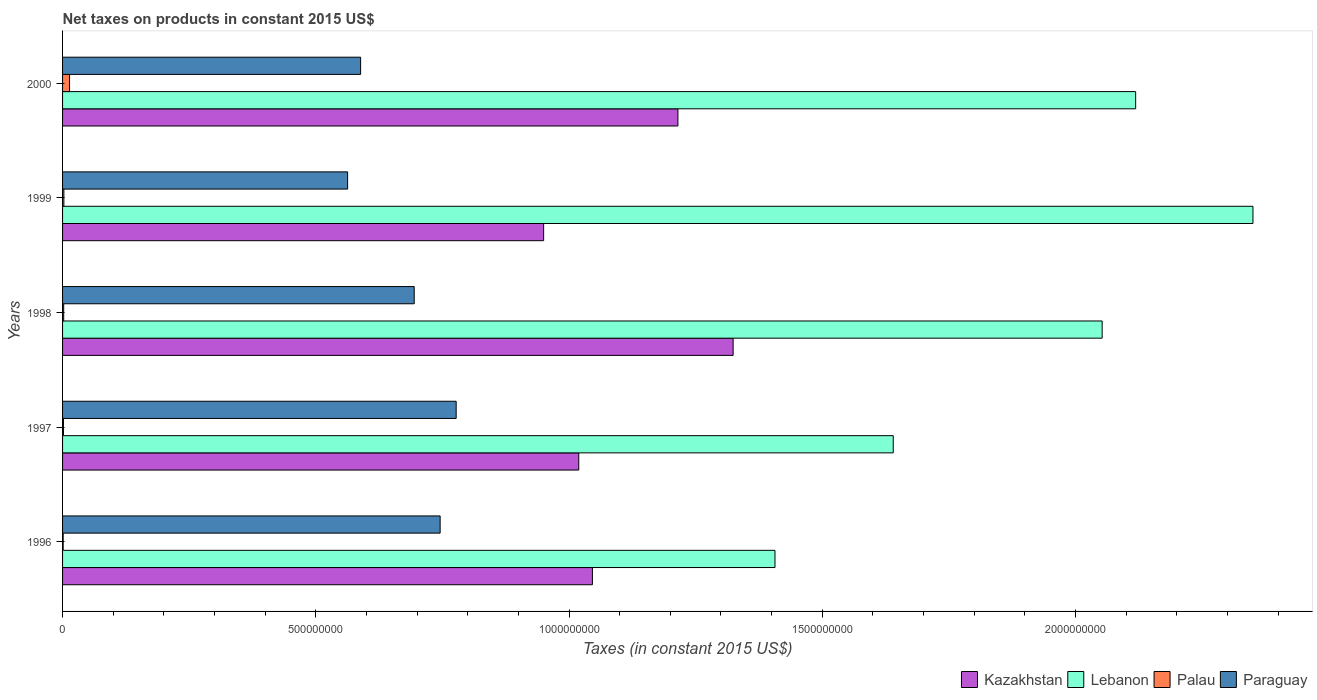Are the number of bars per tick equal to the number of legend labels?
Provide a succinct answer. Yes. How many bars are there on the 3rd tick from the top?
Your answer should be compact. 4. How many bars are there on the 1st tick from the bottom?
Make the answer very short. 4. What is the label of the 2nd group of bars from the top?
Your answer should be very brief. 1999. In how many cases, is the number of bars for a given year not equal to the number of legend labels?
Your answer should be compact. 0. What is the net taxes on products in Palau in 1999?
Your answer should be very brief. 2.59e+06. Across all years, what is the maximum net taxes on products in Lebanon?
Make the answer very short. 2.35e+09. Across all years, what is the minimum net taxes on products in Palau?
Your response must be concise. 1.20e+06. What is the total net taxes on products in Kazakhstan in the graph?
Your response must be concise. 5.55e+09. What is the difference between the net taxes on products in Kazakhstan in 1999 and that in 2000?
Offer a terse response. -2.65e+08. What is the difference between the net taxes on products in Kazakhstan in 1998 and the net taxes on products in Paraguay in 1999?
Your response must be concise. 7.61e+08. What is the average net taxes on products in Palau per year?
Provide a succinct answer. 4.31e+06. In the year 1997, what is the difference between the net taxes on products in Kazakhstan and net taxes on products in Paraguay?
Ensure brevity in your answer.  2.42e+08. In how many years, is the net taxes on products in Kazakhstan greater than 1100000000 US$?
Provide a short and direct response. 2. What is the ratio of the net taxes on products in Paraguay in 1997 to that in 1999?
Give a very brief answer. 1.38. Is the net taxes on products in Palau in 1996 less than that in 1999?
Offer a very short reply. Yes. What is the difference between the highest and the second highest net taxes on products in Lebanon?
Provide a succinct answer. 2.32e+08. What is the difference between the highest and the lowest net taxes on products in Palau?
Offer a terse response. 1.26e+07. In how many years, is the net taxes on products in Kazakhstan greater than the average net taxes on products in Kazakhstan taken over all years?
Your answer should be compact. 2. What does the 2nd bar from the top in 1996 represents?
Keep it short and to the point. Palau. What does the 1st bar from the bottom in 1996 represents?
Your answer should be compact. Kazakhstan. Are all the bars in the graph horizontal?
Your answer should be very brief. Yes. How many years are there in the graph?
Your response must be concise. 5. Where does the legend appear in the graph?
Offer a very short reply. Bottom right. What is the title of the graph?
Provide a short and direct response. Net taxes on products in constant 2015 US$. Does "St. Kitts and Nevis" appear as one of the legend labels in the graph?
Provide a succinct answer. No. What is the label or title of the X-axis?
Your answer should be compact. Taxes (in constant 2015 US$). What is the label or title of the Y-axis?
Offer a terse response. Years. What is the Taxes (in constant 2015 US$) of Kazakhstan in 1996?
Provide a succinct answer. 1.05e+09. What is the Taxes (in constant 2015 US$) in Lebanon in 1996?
Provide a succinct answer. 1.41e+09. What is the Taxes (in constant 2015 US$) in Palau in 1996?
Offer a very short reply. 1.20e+06. What is the Taxes (in constant 2015 US$) in Paraguay in 1996?
Provide a succinct answer. 7.45e+08. What is the Taxes (in constant 2015 US$) of Kazakhstan in 1997?
Your answer should be compact. 1.02e+09. What is the Taxes (in constant 2015 US$) of Lebanon in 1997?
Your answer should be compact. 1.64e+09. What is the Taxes (in constant 2015 US$) of Palau in 1997?
Provide a short and direct response. 1.74e+06. What is the Taxes (in constant 2015 US$) of Paraguay in 1997?
Offer a terse response. 7.77e+08. What is the Taxes (in constant 2015 US$) in Kazakhstan in 1998?
Your response must be concise. 1.32e+09. What is the Taxes (in constant 2015 US$) in Lebanon in 1998?
Provide a succinct answer. 2.05e+09. What is the Taxes (in constant 2015 US$) of Palau in 1998?
Provide a succinct answer. 2.23e+06. What is the Taxes (in constant 2015 US$) in Paraguay in 1998?
Give a very brief answer. 6.94e+08. What is the Taxes (in constant 2015 US$) of Kazakhstan in 1999?
Offer a terse response. 9.50e+08. What is the Taxes (in constant 2015 US$) of Lebanon in 1999?
Offer a terse response. 2.35e+09. What is the Taxes (in constant 2015 US$) in Palau in 1999?
Your response must be concise. 2.59e+06. What is the Taxes (in constant 2015 US$) in Paraguay in 1999?
Keep it short and to the point. 5.63e+08. What is the Taxes (in constant 2015 US$) in Kazakhstan in 2000?
Make the answer very short. 1.21e+09. What is the Taxes (in constant 2015 US$) of Lebanon in 2000?
Provide a short and direct response. 2.12e+09. What is the Taxes (in constant 2015 US$) of Palau in 2000?
Make the answer very short. 1.38e+07. What is the Taxes (in constant 2015 US$) in Paraguay in 2000?
Your answer should be compact. 5.88e+08. Across all years, what is the maximum Taxes (in constant 2015 US$) in Kazakhstan?
Keep it short and to the point. 1.32e+09. Across all years, what is the maximum Taxes (in constant 2015 US$) of Lebanon?
Offer a terse response. 2.35e+09. Across all years, what is the maximum Taxes (in constant 2015 US$) in Palau?
Make the answer very short. 1.38e+07. Across all years, what is the maximum Taxes (in constant 2015 US$) of Paraguay?
Offer a very short reply. 7.77e+08. Across all years, what is the minimum Taxes (in constant 2015 US$) in Kazakhstan?
Give a very brief answer. 9.50e+08. Across all years, what is the minimum Taxes (in constant 2015 US$) in Lebanon?
Your answer should be compact. 1.41e+09. Across all years, what is the minimum Taxes (in constant 2015 US$) of Palau?
Keep it short and to the point. 1.20e+06. Across all years, what is the minimum Taxes (in constant 2015 US$) of Paraguay?
Ensure brevity in your answer.  5.63e+08. What is the total Taxes (in constant 2015 US$) of Kazakhstan in the graph?
Your response must be concise. 5.55e+09. What is the total Taxes (in constant 2015 US$) of Lebanon in the graph?
Your answer should be compact. 9.57e+09. What is the total Taxes (in constant 2015 US$) in Palau in the graph?
Ensure brevity in your answer.  2.16e+07. What is the total Taxes (in constant 2015 US$) in Paraguay in the graph?
Give a very brief answer. 3.37e+09. What is the difference between the Taxes (in constant 2015 US$) of Kazakhstan in 1996 and that in 1997?
Provide a short and direct response. 2.69e+07. What is the difference between the Taxes (in constant 2015 US$) in Lebanon in 1996 and that in 1997?
Provide a short and direct response. -2.34e+08. What is the difference between the Taxes (in constant 2015 US$) in Palau in 1996 and that in 1997?
Your response must be concise. -5.43e+05. What is the difference between the Taxes (in constant 2015 US$) in Paraguay in 1996 and that in 1997?
Ensure brevity in your answer.  -3.17e+07. What is the difference between the Taxes (in constant 2015 US$) in Kazakhstan in 1996 and that in 1998?
Your answer should be very brief. -2.78e+08. What is the difference between the Taxes (in constant 2015 US$) of Lebanon in 1996 and that in 1998?
Your answer should be compact. -6.46e+08. What is the difference between the Taxes (in constant 2015 US$) of Palau in 1996 and that in 1998?
Your answer should be compact. -1.03e+06. What is the difference between the Taxes (in constant 2015 US$) of Paraguay in 1996 and that in 1998?
Your answer should be compact. 5.12e+07. What is the difference between the Taxes (in constant 2015 US$) in Kazakhstan in 1996 and that in 1999?
Make the answer very short. 9.63e+07. What is the difference between the Taxes (in constant 2015 US$) in Lebanon in 1996 and that in 1999?
Your answer should be very brief. -9.44e+08. What is the difference between the Taxes (in constant 2015 US$) of Palau in 1996 and that in 1999?
Ensure brevity in your answer.  -1.39e+06. What is the difference between the Taxes (in constant 2015 US$) of Paraguay in 1996 and that in 1999?
Give a very brief answer. 1.83e+08. What is the difference between the Taxes (in constant 2015 US$) of Kazakhstan in 1996 and that in 2000?
Keep it short and to the point. -1.69e+08. What is the difference between the Taxes (in constant 2015 US$) of Lebanon in 1996 and that in 2000?
Provide a succinct answer. -7.12e+08. What is the difference between the Taxes (in constant 2015 US$) of Palau in 1996 and that in 2000?
Keep it short and to the point. -1.26e+07. What is the difference between the Taxes (in constant 2015 US$) in Paraguay in 1996 and that in 2000?
Offer a terse response. 1.57e+08. What is the difference between the Taxes (in constant 2015 US$) of Kazakhstan in 1997 and that in 1998?
Keep it short and to the point. -3.05e+08. What is the difference between the Taxes (in constant 2015 US$) of Lebanon in 1997 and that in 1998?
Offer a terse response. -4.12e+08. What is the difference between the Taxes (in constant 2015 US$) of Palau in 1997 and that in 1998?
Make the answer very short. -4.88e+05. What is the difference between the Taxes (in constant 2015 US$) of Paraguay in 1997 and that in 1998?
Provide a short and direct response. 8.28e+07. What is the difference between the Taxes (in constant 2015 US$) in Kazakhstan in 1997 and that in 1999?
Your answer should be very brief. 6.93e+07. What is the difference between the Taxes (in constant 2015 US$) in Lebanon in 1997 and that in 1999?
Provide a short and direct response. -7.10e+08. What is the difference between the Taxes (in constant 2015 US$) in Palau in 1997 and that in 1999?
Your answer should be compact. -8.47e+05. What is the difference between the Taxes (in constant 2015 US$) of Paraguay in 1997 and that in 1999?
Your response must be concise. 2.14e+08. What is the difference between the Taxes (in constant 2015 US$) in Kazakhstan in 1997 and that in 2000?
Give a very brief answer. -1.96e+08. What is the difference between the Taxes (in constant 2015 US$) of Lebanon in 1997 and that in 2000?
Your answer should be very brief. -4.79e+08. What is the difference between the Taxes (in constant 2015 US$) of Palau in 1997 and that in 2000?
Provide a short and direct response. -1.21e+07. What is the difference between the Taxes (in constant 2015 US$) in Paraguay in 1997 and that in 2000?
Give a very brief answer. 1.89e+08. What is the difference between the Taxes (in constant 2015 US$) in Kazakhstan in 1998 and that in 1999?
Ensure brevity in your answer.  3.74e+08. What is the difference between the Taxes (in constant 2015 US$) of Lebanon in 1998 and that in 1999?
Keep it short and to the point. -2.98e+08. What is the difference between the Taxes (in constant 2015 US$) in Palau in 1998 and that in 1999?
Give a very brief answer. -3.59e+05. What is the difference between the Taxes (in constant 2015 US$) of Paraguay in 1998 and that in 1999?
Your response must be concise. 1.32e+08. What is the difference between the Taxes (in constant 2015 US$) in Kazakhstan in 1998 and that in 2000?
Make the answer very short. 1.09e+08. What is the difference between the Taxes (in constant 2015 US$) of Lebanon in 1998 and that in 2000?
Make the answer very short. -6.61e+07. What is the difference between the Taxes (in constant 2015 US$) in Palau in 1998 and that in 2000?
Offer a terse response. -1.16e+07. What is the difference between the Taxes (in constant 2015 US$) in Paraguay in 1998 and that in 2000?
Offer a very short reply. 1.06e+08. What is the difference between the Taxes (in constant 2015 US$) in Kazakhstan in 1999 and that in 2000?
Ensure brevity in your answer.  -2.65e+08. What is the difference between the Taxes (in constant 2015 US$) of Lebanon in 1999 and that in 2000?
Make the answer very short. 2.32e+08. What is the difference between the Taxes (in constant 2015 US$) of Palau in 1999 and that in 2000?
Make the answer very short. -1.12e+07. What is the difference between the Taxes (in constant 2015 US$) of Paraguay in 1999 and that in 2000?
Provide a short and direct response. -2.57e+07. What is the difference between the Taxes (in constant 2015 US$) of Kazakhstan in 1996 and the Taxes (in constant 2015 US$) of Lebanon in 1997?
Ensure brevity in your answer.  -5.94e+08. What is the difference between the Taxes (in constant 2015 US$) in Kazakhstan in 1996 and the Taxes (in constant 2015 US$) in Palau in 1997?
Your answer should be very brief. 1.04e+09. What is the difference between the Taxes (in constant 2015 US$) in Kazakhstan in 1996 and the Taxes (in constant 2015 US$) in Paraguay in 1997?
Offer a terse response. 2.69e+08. What is the difference between the Taxes (in constant 2015 US$) of Lebanon in 1996 and the Taxes (in constant 2015 US$) of Palau in 1997?
Your answer should be very brief. 1.40e+09. What is the difference between the Taxes (in constant 2015 US$) in Lebanon in 1996 and the Taxes (in constant 2015 US$) in Paraguay in 1997?
Keep it short and to the point. 6.29e+08. What is the difference between the Taxes (in constant 2015 US$) of Palau in 1996 and the Taxes (in constant 2015 US$) of Paraguay in 1997?
Your response must be concise. -7.76e+08. What is the difference between the Taxes (in constant 2015 US$) of Kazakhstan in 1996 and the Taxes (in constant 2015 US$) of Lebanon in 1998?
Provide a short and direct response. -1.01e+09. What is the difference between the Taxes (in constant 2015 US$) in Kazakhstan in 1996 and the Taxes (in constant 2015 US$) in Palau in 1998?
Your response must be concise. 1.04e+09. What is the difference between the Taxes (in constant 2015 US$) of Kazakhstan in 1996 and the Taxes (in constant 2015 US$) of Paraguay in 1998?
Make the answer very short. 3.52e+08. What is the difference between the Taxes (in constant 2015 US$) of Lebanon in 1996 and the Taxes (in constant 2015 US$) of Palau in 1998?
Offer a very short reply. 1.40e+09. What is the difference between the Taxes (in constant 2015 US$) of Lebanon in 1996 and the Taxes (in constant 2015 US$) of Paraguay in 1998?
Provide a succinct answer. 7.12e+08. What is the difference between the Taxes (in constant 2015 US$) of Palau in 1996 and the Taxes (in constant 2015 US$) of Paraguay in 1998?
Provide a succinct answer. -6.93e+08. What is the difference between the Taxes (in constant 2015 US$) in Kazakhstan in 1996 and the Taxes (in constant 2015 US$) in Lebanon in 1999?
Your answer should be very brief. -1.30e+09. What is the difference between the Taxes (in constant 2015 US$) of Kazakhstan in 1996 and the Taxes (in constant 2015 US$) of Palau in 1999?
Your answer should be very brief. 1.04e+09. What is the difference between the Taxes (in constant 2015 US$) in Kazakhstan in 1996 and the Taxes (in constant 2015 US$) in Paraguay in 1999?
Provide a short and direct response. 4.83e+08. What is the difference between the Taxes (in constant 2015 US$) in Lebanon in 1996 and the Taxes (in constant 2015 US$) in Palau in 1999?
Provide a succinct answer. 1.40e+09. What is the difference between the Taxes (in constant 2015 US$) of Lebanon in 1996 and the Taxes (in constant 2015 US$) of Paraguay in 1999?
Your answer should be compact. 8.44e+08. What is the difference between the Taxes (in constant 2015 US$) of Palau in 1996 and the Taxes (in constant 2015 US$) of Paraguay in 1999?
Your response must be concise. -5.62e+08. What is the difference between the Taxes (in constant 2015 US$) in Kazakhstan in 1996 and the Taxes (in constant 2015 US$) in Lebanon in 2000?
Your answer should be compact. -1.07e+09. What is the difference between the Taxes (in constant 2015 US$) of Kazakhstan in 1996 and the Taxes (in constant 2015 US$) of Palau in 2000?
Offer a very short reply. 1.03e+09. What is the difference between the Taxes (in constant 2015 US$) of Kazakhstan in 1996 and the Taxes (in constant 2015 US$) of Paraguay in 2000?
Provide a short and direct response. 4.58e+08. What is the difference between the Taxes (in constant 2015 US$) in Lebanon in 1996 and the Taxes (in constant 2015 US$) in Palau in 2000?
Your answer should be compact. 1.39e+09. What is the difference between the Taxes (in constant 2015 US$) of Lebanon in 1996 and the Taxes (in constant 2015 US$) of Paraguay in 2000?
Offer a very short reply. 8.18e+08. What is the difference between the Taxes (in constant 2015 US$) in Palau in 1996 and the Taxes (in constant 2015 US$) in Paraguay in 2000?
Keep it short and to the point. -5.87e+08. What is the difference between the Taxes (in constant 2015 US$) in Kazakhstan in 1997 and the Taxes (in constant 2015 US$) in Lebanon in 1998?
Your answer should be very brief. -1.03e+09. What is the difference between the Taxes (in constant 2015 US$) in Kazakhstan in 1997 and the Taxes (in constant 2015 US$) in Palau in 1998?
Offer a very short reply. 1.02e+09. What is the difference between the Taxes (in constant 2015 US$) in Kazakhstan in 1997 and the Taxes (in constant 2015 US$) in Paraguay in 1998?
Your response must be concise. 3.25e+08. What is the difference between the Taxes (in constant 2015 US$) of Lebanon in 1997 and the Taxes (in constant 2015 US$) of Palau in 1998?
Ensure brevity in your answer.  1.64e+09. What is the difference between the Taxes (in constant 2015 US$) of Lebanon in 1997 and the Taxes (in constant 2015 US$) of Paraguay in 1998?
Your answer should be very brief. 9.46e+08. What is the difference between the Taxes (in constant 2015 US$) of Palau in 1997 and the Taxes (in constant 2015 US$) of Paraguay in 1998?
Your answer should be compact. -6.93e+08. What is the difference between the Taxes (in constant 2015 US$) in Kazakhstan in 1997 and the Taxes (in constant 2015 US$) in Lebanon in 1999?
Provide a succinct answer. -1.33e+09. What is the difference between the Taxes (in constant 2015 US$) in Kazakhstan in 1997 and the Taxes (in constant 2015 US$) in Palau in 1999?
Your answer should be compact. 1.02e+09. What is the difference between the Taxes (in constant 2015 US$) of Kazakhstan in 1997 and the Taxes (in constant 2015 US$) of Paraguay in 1999?
Ensure brevity in your answer.  4.56e+08. What is the difference between the Taxes (in constant 2015 US$) in Lebanon in 1997 and the Taxes (in constant 2015 US$) in Palau in 1999?
Your answer should be compact. 1.64e+09. What is the difference between the Taxes (in constant 2015 US$) of Lebanon in 1997 and the Taxes (in constant 2015 US$) of Paraguay in 1999?
Provide a short and direct response. 1.08e+09. What is the difference between the Taxes (in constant 2015 US$) in Palau in 1997 and the Taxes (in constant 2015 US$) in Paraguay in 1999?
Give a very brief answer. -5.61e+08. What is the difference between the Taxes (in constant 2015 US$) of Kazakhstan in 1997 and the Taxes (in constant 2015 US$) of Lebanon in 2000?
Provide a succinct answer. -1.10e+09. What is the difference between the Taxes (in constant 2015 US$) of Kazakhstan in 1997 and the Taxes (in constant 2015 US$) of Palau in 2000?
Keep it short and to the point. 1.01e+09. What is the difference between the Taxes (in constant 2015 US$) in Kazakhstan in 1997 and the Taxes (in constant 2015 US$) in Paraguay in 2000?
Keep it short and to the point. 4.31e+08. What is the difference between the Taxes (in constant 2015 US$) in Lebanon in 1997 and the Taxes (in constant 2015 US$) in Palau in 2000?
Keep it short and to the point. 1.63e+09. What is the difference between the Taxes (in constant 2015 US$) in Lebanon in 1997 and the Taxes (in constant 2015 US$) in Paraguay in 2000?
Keep it short and to the point. 1.05e+09. What is the difference between the Taxes (in constant 2015 US$) in Palau in 1997 and the Taxes (in constant 2015 US$) in Paraguay in 2000?
Offer a terse response. -5.87e+08. What is the difference between the Taxes (in constant 2015 US$) of Kazakhstan in 1998 and the Taxes (in constant 2015 US$) of Lebanon in 1999?
Provide a succinct answer. -1.03e+09. What is the difference between the Taxes (in constant 2015 US$) of Kazakhstan in 1998 and the Taxes (in constant 2015 US$) of Palau in 1999?
Give a very brief answer. 1.32e+09. What is the difference between the Taxes (in constant 2015 US$) in Kazakhstan in 1998 and the Taxes (in constant 2015 US$) in Paraguay in 1999?
Ensure brevity in your answer.  7.61e+08. What is the difference between the Taxes (in constant 2015 US$) of Lebanon in 1998 and the Taxes (in constant 2015 US$) of Palau in 1999?
Keep it short and to the point. 2.05e+09. What is the difference between the Taxes (in constant 2015 US$) in Lebanon in 1998 and the Taxes (in constant 2015 US$) in Paraguay in 1999?
Make the answer very short. 1.49e+09. What is the difference between the Taxes (in constant 2015 US$) of Palau in 1998 and the Taxes (in constant 2015 US$) of Paraguay in 1999?
Your answer should be very brief. -5.61e+08. What is the difference between the Taxes (in constant 2015 US$) in Kazakhstan in 1998 and the Taxes (in constant 2015 US$) in Lebanon in 2000?
Offer a very short reply. -7.95e+08. What is the difference between the Taxes (in constant 2015 US$) in Kazakhstan in 1998 and the Taxes (in constant 2015 US$) in Palau in 2000?
Ensure brevity in your answer.  1.31e+09. What is the difference between the Taxes (in constant 2015 US$) in Kazakhstan in 1998 and the Taxes (in constant 2015 US$) in Paraguay in 2000?
Provide a succinct answer. 7.35e+08. What is the difference between the Taxes (in constant 2015 US$) in Lebanon in 1998 and the Taxes (in constant 2015 US$) in Palau in 2000?
Provide a short and direct response. 2.04e+09. What is the difference between the Taxes (in constant 2015 US$) in Lebanon in 1998 and the Taxes (in constant 2015 US$) in Paraguay in 2000?
Your answer should be very brief. 1.46e+09. What is the difference between the Taxes (in constant 2015 US$) in Palau in 1998 and the Taxes (in constant 2015 US$) in Paraguay in 2000?
Give a very brief answer. -5.86e+08. What is the difference between the Taxes (in constant 2015 US$) of Kazakhstan in 1999 and the Taxes (in constant 2015 US$) of Lebanon in 2000?
Your response must be concise. -1.17e+09. What is the difference between the Taxes (in constant 2015 US$) in Kazakhstan in 1999 and the Taxes (in constant 2015 US$) in Palau in 2000?
Offer a terse response. 9.36e+08. What is the difference between the Taxes (in constant 2015 US$) of Kazakhstan in 1999 and the Taxes (in constant 2015 US$) of Paraguay in 2000?
Provide a short and direct response. 3.61e+08. What is the difference between the Taxes (in constant 2015 US$) of Lebanon in 1999 and the Taxes (in constant 2015 US$) of Palau in 2000?
Provide a short and direct response. 2.34e+09. What is the difference between the Taxes (in constant 2015 US$) in Lebanon in 1999 and the Taxes (in constant 2015 US$) in Paraguay in 2000?
Give a very brief answer. 1.76e+09. What is the difference between the Taxes (in constant 2015 US$) of Palau in 1999 and the Taxes (in constant 2015 US$) of Paraguay in 2000?
Your answer should be compact. -5.86e+08. What is the average Taxes (in constant 2015 US$) in Kazakhstan per year?
Keep it short and to the point. 1.11e+09. What is the average Taxes (in constant 2015 US$) in Lebanon per year?
Provide a succinct answer. 1.91e+09. What is the average Taxes (in constant 2015 US$) in Palau per year?
Keep it short and to the point. 4.31e+06. What is the average Taxes (in constant 2015 US$) in Paraguay per year?
Your answer should be very brief. 6.74e+08. In the year 1996, what is the difference between the Taxes (in constant 2015 US$) of Kazakhstan and Taxes (in constant 2015 US$) of Lebanon?
Keep it short and to the point. -3.60e+08. In the year 1996, what is the difference between the Taxes (in constant 2015 US$) in Kazakhstan and Taxes (in constant 2015 US$) in Palau?
Your answer should be compact. 1.04e+09. In the year 1996, what is the difference between the Taxes (in constant 2015 US$) in Kazakhstan and Taxes (in constant 2015 US$) in Paraguay?
Your answer should be compact. 3.01e+08. In the year 1996, what is the difference between the Taxes (in constant 2015 US$) of Lebanon and Taxes (in constant 2015 US$) of Palau?
Give a very brief answer. 1.41e+09. In the year 1996, what is the difference between the Taxes (in constant 2015 US$) of Lebanon and Taxes (in constant 2015 US$) of Paraguay?
Your answer should be very brief. 6.61e+08. In the year 1996, what is the difference between the Taxes (in constant 2015 US$) of Palau and Taxes (in constant 2015 US$) of Paraguay?
Provide a short and direct response. -7.44e+08. In the year 1997, what is the difference between the Taxes (in constant 2015 US$) in Kazakhstan and Taxes (in constant 2015 US$) in Lebanon?
Provide a short and direct response. -6.21e+08. In the year 1997, what is the difference between the Taxes (in constant 2015 US$) of Kazakhstan and Taxes (in constant 2015 US$) of Palau?
Keep it short and to the point. 1.02e+09. In the year 1997, what is the difference between the Taxes (in constant 2015 US$) of Kazakhstan and Taxes (in constant 2015 US$) of Paraguay?
Give a very brief answer. 2.42e+08. In the year 1997, what is the difference between the Taxes (in constant 2015 US$) of Lebanon and Taxes (in constant 2015 US$) of Palau?
Give a very brief answer. 1.64e+09. In the year 1997, what is the difference between the Taxes (in constant 2015 US$) of Lebanon and Taxes (in constant 2015 US$) of Paraguay?
Offer a terse response. 8.63e+08. In the year 1997, what is the difference between the Taxes (in constant 2015 US$) of Palau and Taxes (in constant 2015 US$) of Paraguay?
Give a very brief answer. -7.75e+08. In the year 1998, what is the difference between the Taxes (in constant 2015 US$) in Kazakhstan and Taxes (in constant 2015 US$) in Lebanon?
Keep it short and to the point. -7.29e+08. In the year 1998, what is the difference between the Taxes (in constant 2015 US$) in Kazakhstan and Taxes (in constant 2015 US$) in Palau?
Ensure brevity in your answer.  1.32e+09. In the year 1998, what is the difference between the Taxes (in constant 2015 US$) in Kazakhstan and Taxes (in constant 2015 US$) in Paraguay?
Offer a terse response. 6.30e+08. In the year 1998, what is the difference between the Taxes (in constant 2015 US$) in Lebanon and Taxes (in constant 2015 US$) in Palau?
Your response must be concise. 2.05e+09. In the year 1998, what is the difference between the Taxes (in constant 2015 US$) in Lebanon and Taxes (in constant 2015 US$) in Paraguay?
Provide a succinct answer. 1.36e+09. In the year 1998, what is the difference between the Taxes (in constant 2015 US$) in Palau and Taxes (in constant 2015 US$) in Paraguay?
Ensure brevity in your answer.  -6.92e+08. In the year 1999, what is the difference between the Taxes (in constant 2015 US$) in Kazakhstan and Taxes (in constant 2015 US$) in Lebanon?
Ensure brevity in your answer.  -1.40e+09. In the year 1999, what is the difference between the Taxes (in constant 2015 US$) in Kazakhstan and Taxes (in constant 2015 US$) in Palau?
Make the answer very short. 9.47e+08. In the year 1999, what is the difference between the Taxes (in constant 2015 US$) of Kazakhstan and Taxes (in constant 2015 US$) of Paraguay?
Your answer should be compact. 3.87e+08. In the year 1999, what is the difference between the Taxes (in constant 2015 US$) of Lebanon and Taxes (in constant 2015 US$) of Palau?
Make the answer very short. 2.35e+09. In the year 1999, what is the difference between the Taxes (in constant 2015 US$) of Lebanon and Taxes (in constant 2015 US$) of Paraguay?
Your answer should be very brief. 1.79e+09. In the year 1999, what is the difference between the Taxes (in constant 2015 US$) of Palau and Taxes (in constant 2015 US$) of Paraguay?
Give a very brief answer. -5.60e+08. In the year 2000, what is the difference between the Taxes (in constant 2015 US$) of Kazakhstan and Taxes (in constant 2015 US$) of Lebanon?
Ensure brevity in your answer.  -9.04e+08. In the year 2000, what is the difference between the Taxes (in constant 2015 US$) in Kazakhstan and Taxes (in constant 2015 US$) in Palau?
Ensure brevity in your answer.  1.20e+09. In the year 2000, what is the difference between the Taxes (in constant 2015 US$) of Kazakhstan and Taxes (in constant 2015 US$) of Paraguay?
Keep it short and to the point. 6.26e+08. In the year 2000, what is the difference between the Taxes (in constant 2015 US$) of Lebanon and Taxes (in constant 2015 US$) of Palau?
Your response must be concise. 2.10e+09. In the year 2000, what is the difference between the Taxes (in constant 2015 US$) in Lebanon and Taxes (in constant 2015 US$) in Paraguay?
Ensure brevity in your answer.  1.53e+09. In the year 2000, what is the difference between the Taxes (in constant 2015 US$) of Palau and Taxes (in constant 2015 US$) of Paraguay?
Your answer should be compact. -5.75e+08. What is the ratio of the Taxes (in constant 2015 US$) in Kazakhstan in 1996 to that in 1997?
Keep it short and to the point. 1.03. What is the ratio of the Taxes (in constant 2015 US$) in Lebanon in 1996 to that in 1997?
Offer a terse response. 0.86. What is the ratio of the Taxes (in constant 2015 US$) of Palau in 1996 to that in 1997?
Your response must be concise. 0.69. What is the ratio of the Taxes (in constant 2015 US$) of Paraguay in 1996 to that in 1997?
Provide a succinct answer. 0.96. What is the ratio of the Taxes (in constant 2015 US$) of Kazakhstan in 1996 to that in 1998?
Offer a terse response. 0.79. What is the ratio of the Taxes (in constant 2015 US$) of Lebanon in 1996 to that in 1998?
Make the answer very short. 0.69. What is the ratio of the Taxes (in constant 2015 US$) in Palau in 1996 to that in 1998?
Ensure brevity in your answer.  0.54. What is the ratio of the Taxes (in constant 2015 US$) in Paraguay in 1996 to that in 1998?
Provide a succinct answer. 1.07. What is the ratio of the Taxes (in constant 2015 US$) in Kazakhstan in 1996 to that in 1999?
Ensure brevity in your answer.  1.1. What is the ratio of the Taxes (in constant 2015 US$) in Lebanon in 1996 to that in 1999?
Ensure brevity in your answer.  0.6. What is the ratio of the Taxes (in constant 2015 US$) of Palau in 1996 to that in 1999?
Your response must be concise. 0.46. What is the ratio of the Taxes (in constant 2015 US$) in Paraguay in 1996 to that in 1999?
Give a very brief answer. 1.32. What is the ratio of the Taxes (in constant 2015 US$) in Kazakhstan in 1996 to that in 2000?
Offer a terse response. 0.86. What is the ratio of the Taxes (in constant 2015 US$) of Lebanon in 1996 to that in 2000?
Your answer should be very brief. 0.66. What is the ratio of the Taxes (in constant 2015 US$) in Palau in 1996 to that in 2000?
Keep it short and to the point. 0.09. What is the ratio of the Taxes (in constant 2015 US$) in Paraguay in 1996 to that in 2000?
Make the answer very short. 1.27. What is the ratio of the Taxes (in constant 2015 US$) in Kazakhstan in 1997 to that in 1998?
Your answer should be very brief. 0.77. What is the ratio of the Taxes (in constant 2015 US$) of Lebanon in 1997 to that in 1998?
Provide a short and direct response. 0.8. What is the ratio of the Taxes (in constant 2015 US$) in Palau in 1997 to that in 1998?
Make the answer very short. 0.78. What is the ratio of the Taxes (in constant 2015 US$) in Paraguay in 1997 to that in 1998?
Keep it short and to the point. 1.12. What is the ratio of the Taxes (in constant 2015 US$) in Kazakhstan in 1997 to that in 1999?
Make the answer very short. 1.07. What is the ratio of the Taxes (in constant 2015 US$) of Lebanon in 1997 to that in 1999?
Your response must be concise. 0.7. What is the ratio of the Taxes (in constant 2015 US$) of Palau in 1997 to that in 1999?
Provide a short and direct response. 0.67. What is the ratio of the Taxes (in constant 2015 US$) of Paraguay in 1997 to that in 1999?
Offer a terse response. 1.38. What is the ratio of the Taxes (in constant 2015 US$) in Kazakhstan in 1997 to that in 2000?
Provide a succinct answer. 0.84. What is the ratio of the Taxes (in constant 2015 US$) of Lebanon in 1997 to that in 2000?
Keep it short and to the point. 0.77. What is the ratio of the Taxes (in constant 2015 US$) of Palau in 1997 to that in 2000?
Your answer should be very brief. 0.13. What is the ratio of the Taxes (in constant 2015 US$) in Paraguay in 1997 to that in 2000?
Your answer should be very brief. 1.32. What is the ratio of the Taxes (in constant 2015 US$) of Kazakhstan in 1998 to that in 1999?
Ensure brevity in your answer.  1.39. What is the ratio of the Taxes (in constant 2015 US$) in Lebanon in 1998 to that in 1999?
Your answer should be compact. 0.87. What is the ratio of the Taxes (in constant 2015 US$) of Palau in 1998 to that in 1999?
Ensure brevity in your answer.  0.86. What is the ratio of the Taxes (in constant 2015 US$) of Paraguay in 1998 to that in 1999?
Give a very brief answer. 1.23. What is the ratio of the Taxes (in constant 2015 US$) of Kazakhstan in 1998 to that in 2000?
Your answer should be compact. 1.09. What is the ratio of the Taxes (in constant 2015 US$) of Lebanon in 1998 to that in 2000?
Your answer should be compact. 0.97. What is the ratio of the Taxes (in constant 2015 US$) in Palau in 1998 to that in 2000?
Provide a succinct answer. 0.16. What is the ratio of the Taxes (in constant 2015 US$) of Paraguay in 1998 to that in 2000?
Your response must be concise. 1.18. What is the ratio of the Taxes (in constant 2015 US$) in Kazakhstan in 1999 to that in 2000?
Keep it short and to the point. 0.78. What is the ratio of the Taxes (in constant 2015 US$) in Lebanon in 1999 to that in 2000?
Offer a very short reply. 1.11. What is the ratio of the Taxes (in constant 2015 US$) in Palau in 1999 to that in 2000?
Make the answer very short. 0.19. What is the ratio of the Taxes (in constant 2015 US$) in Paraguay in 1999 to that in 2000?
Offer a terse response. 0.96. What is the difference between the highest and the second highest Taxes (in constant 2015 US$) in Kazakhstan?
Give a very brief answer. 1.09e+08. What is the difference between the highest and the second highest Taxes (in constant 2015 US$) of Lebanon?
Make the answer very short. 2.32e+08. What is the difference between the highest and the second highest Taxes (in constant 2015 US$) in Palau?
Ensure brevity in your answer.  1.12e+07. What is the difference between the highest and the second highest Taxes (in constant 2015 US$) of Paraguay?
Your answer should be compact. 3.17e+07. What is the difference between the highest and the lowest Taxes (in constant 2015 US$) of Kazakhstan?
Your answer should be compact. 3.74e+08. What is the difference between the highest and the lowest Taxes (in constant 2015 US$) in Lebanon?
Provide a succinct answer. 9.44e+08. What is the difference between the highest and the lowest Taxes (in constant 2015 US$) of Palau?
Keep it short and to the point. 1.26e+07. What is the difference between the highest and the lowest Taxes (in constant 2015 US$) of Paraguay?
Keep it short and to the point. 2.14e+08. 